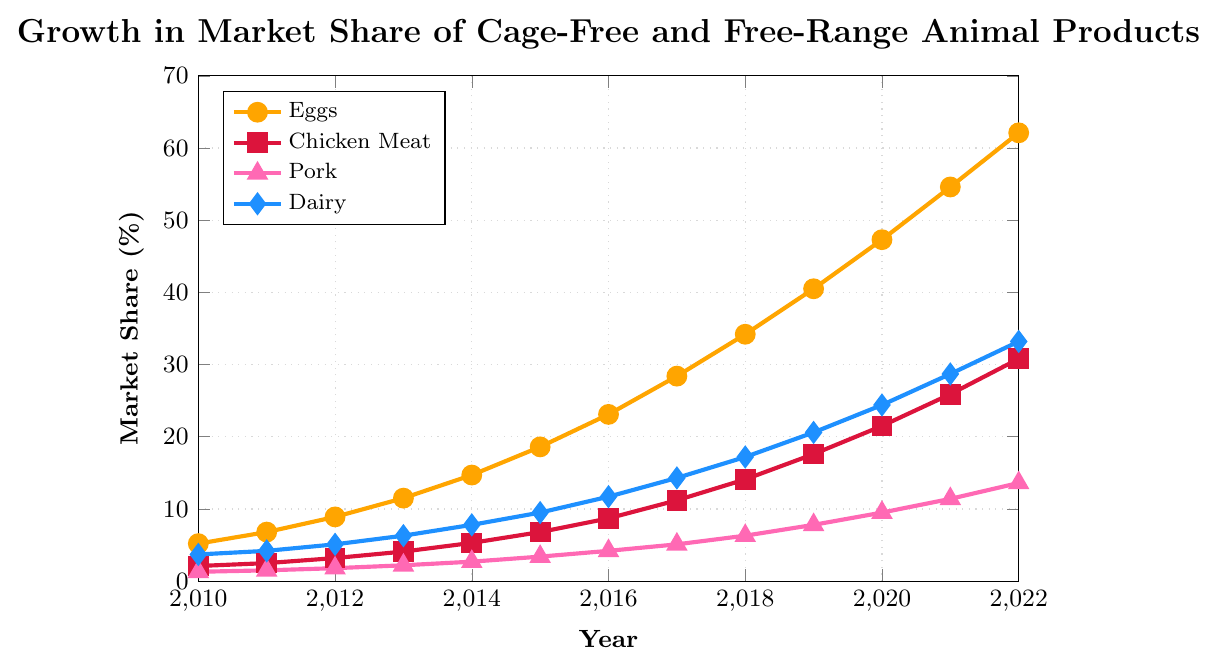Which product category shows the highest market share increase from 2010 to 2022? From the figure, visually identify the category with the largest increase in market share. Eggs go from 5.2% to 62.1%, Chicken Meat from 2.1% to 30.8%, Pork from 1.3% to 13.6%, and Dairy from 3.7% to 33.2%. Calculate the increase for each category: Eggs (62.1-5.2 = 56.9), Chicken Meat (30.8-2.1 = 28.7), Pork (13.6-1.3 = 12.3), and Dairy (33.2-3.7 = 29.5).
Answer: Eggs What is the average market share of cage-free and free-range Dairy products from 2010 to 2022? Sum all the Dairy market shares from 2010 to 2022 and divide by the number of years. (3.7 + 4.2 + 5.1 + 6.3 + 7.8 + 9.5 + 11.7 + 14.3 + 17.2 + 20.6 + 24.4 + 28.7 + 33.2) / 13 ≈ 14.5%
Answer: 14.5% In what year did Pork products see the largest single-year increase in market share? Compare the year-on-year increases in market share for Pork: 2011 (1.5 - 1.3 = 0.2), 2012 (1.8 - 1.5 = 0.3), 2013 (2.2 - 1.8 = 0.4), 2014 (2.7 - 2.2 = 0.5), 2015 (3.4 - 2.7 = 0.7), 2016 (4.2 - 3.4 = 0.8), 2017 (5.1 - 4.2 = 0.9), 2018 (6.3 - 5.1 = 1.2), 2019 (7.8 - 6.3 = 1.5), 2020 (9.5 - 7.8 = 1.7), 2021 (11.4 - 9.5 = 1.9), 2022 (13.6 - 11.4 = 2.2). The largest single-year increase is from 2021 to 2022 (2.2).
Answer: 2022 How does the market share of Chicken Meat in 2012 compare to that of Dairy in 2017? Identify and compare the respective market shares from the given years: Chicken Meat in 2012 is 3.2% and Dairy in 2017 is 14.3%. Chicken Meat in 2012 is much lower than Dairy in 2017.
Answer: Chicken Meat is lower What product category showed the most consistent year-on-year growth from 2010 to 2022? Evaluate the trends for all categories by visually comparing their curves. Eggs show a consistent upward curve without significant fluctuations, indicating steady growth.
Answer: Eggs Between which consecutive years did the market share of Eggs increase the most? Calculate the year-on-year increases for Eggs: 2011 (6.8-5.2 = 1.6), 2012 (8.9-6.8 = 2.1), 2013 (11.5-8.9 = 2.6), 2014 (14.7-11.5 = 3.2), 2015 (18.6-14.7 = 3.9), 2016 (23.1-18.6 = 4.5), 2017 (28.4-23.1 = 5.3), 2018 (34.2-28.4 = 5.8), 2019 (40.5-34.2 = 6.3), 2020 (47.3-40.5 = 6.8), 2021 (54.6-47.3 = 7.3), 2022 (62.1-54.6 = 7.5). The largest increase is between 2021 and 2022 (7.5).
Answer: 2021-2022 What was the market share of Dairy products in 2020? Identify the market share of Dairy for the year 2020 directly from the graph, which is marked at 24.4%.
Answer: 24.4% 